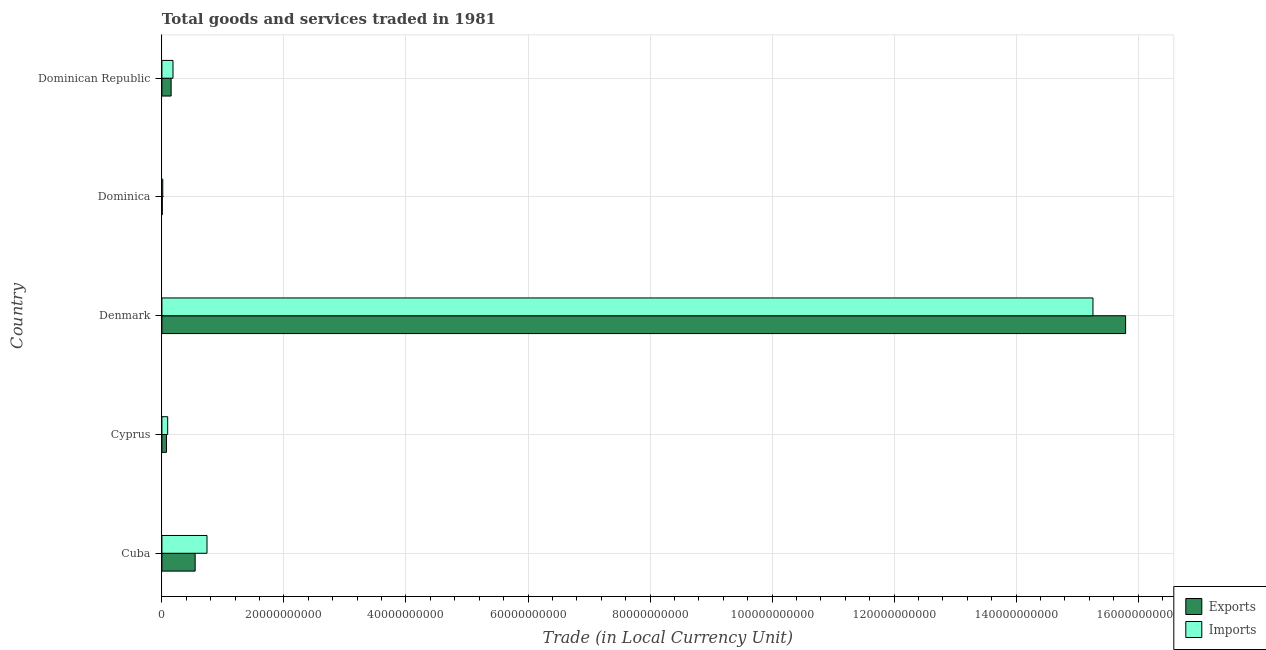Are the number of bars per tick equal to the number of legend labels?
Provide a short and direct response. Yes. What is the label of the 4th group of bars from the top?
Your answer should be very brief. Cyprus. What is the export of goods and services in Denmark?
Provide a short and direct response. 1.58e+11. Across all countries, what is the maximum imports of goods and services?
Make the answer very short. 1.53e+11. Across all countries, what is the minimum export of goods and services?
Offer a very short reply. 6.18e+07. In which country was the export of goods and services maximum?
Your answer should be compact. Denmark. In which country was the imports of goods and services minimum?
Ensure brevity in your answer.  Dominica. What is the total export of goods and services in the graph?
Offer a very short reply. 1.66e+11. What is the difference between the export of goods and services in Cuba and that in Denmark?
Your response must be concise. -1.52e+11. What is the difference between the imports of goods and services in Dominican Republic and the export of goods and services in Cuba?
Your answer should be very brief. -3.63e+09. What is the average imports of goods and services per country?
Your answer should be very brief. 3.26e+1. What is the difference between the export of goods and services and imports of goods and services in Denmark?
Your answer should be compact. 5.35e+09. What is the ratio of the imports of goods and services in Cuba to that in Dominican Republic?
Provide a short and direct response. 4.07. Is the difference between the imports of goods and services in Cuba and Denmark greater than the difference between the export of goods and services in Cuba and Denmark?
Your response must be concise. Yes. What is the difference between the highest and the second highest imports of goods and services?
Make the answer very short. 1.45e+11. What is the difference between the highest and the lowest imports of goods and services?
Your answer should be very brief. 1.52e+11. In how many countries, is the export of goods and services greater than the average export of goods and services taken over all countries?
Offer a terse response. 1. What does the 1st bar from the top in Dominica represents?
Ensure brevity in your answer.  Imports. What does the 2nd bar from the bottom in Dominica represents?
Provide a succinct answer. Imports. How many bars are there?
Keep it short and to the point. 10. Are all the bars in the graph horizontal?
Ensure brevity in your answer.  Yes. How many countries are there in the graph?
Offer a very short reply. 5. What is the difference between two consecutive major ticks on the X-axis?
Offer a very short reply. 2.00e+1. Are the values on the major ticks of X-axis written in scientific E-notation?
Ensure brevity in your answer.  No. Does the graph contain any zero values?
Your response must be concise. No. How many legend labels are there?
Keep it short and to the point. 2. How are the legend labels stacked?
Your answer should be very brief. Vertical. What is the title of the graph?
Provide a short and direct response. Total goods and services traded in 1981. What is the label or title of the X-axis?
Your response must be concise. Trade (in Local Currency Unit). What is the Trade (in Local Currency Unit) of Exports in Cuba?
Keep it short and to the point. 5.45e+09. What is the Trade (in Local Currency Unit) of Imports in Cuba?
Offer a terse response. 7.39e+09. What is the Trade (in Local Currency Unit) of Exports in Cyprus?
Make the answer very short. 7.52e+08. What is the Trade (in Local Currency Unit) of Imports in Cyprus?
Make the answer very short. 9.48e+08. What is the Trade (in Local Currency Unit) of Exports in Denmark?
Your answer should be compact. 1.58e+11. What is the Trade (in Local Currency Unit) of Imports in Denmark?
Your response must be concise. 1.53e+11. What is the Trade (in Local Currency Unit) of Exports in Dominica?
Keep it short and to the point. 6.18e+07. What is the Trade (in Local Currency Unit) in Imports in Dominica?
Your answer should be compact. 1.41e+08. What is the Trade (in Local Currency Unit) in Exports in Dominican Republic?
Keep it short and to the point. 1.51e+09. What is the Trade (in Local Currency Unit) of Imports in Dominican Republic?
Provide a short and direct response. 1.82e+09. Across all countries, what is the maximum Trade (in Local Currency Unit) of Exports?
Make the answer very short. 1.58e+11. Across all countries, what is the maximum Trade (in Local Currency Unit) in Imports?
Offer a terse response. 1.53e+11. Across all countries, what is the minimum Trade (in Local Currency Unit) in Exports?
Offer a very short reply. 6.18e+07. Across all countries, what is the minimum Trade (in Local Currency Unit) in Imports?
Provide a short and direct response. 1.41e+08. What is the total Trade (in Local Currency Unit) of Exports in the graph?
Your answer should be very brief. 1.66e+11. What is the total Trade (in Local Currency Unit) in Imports in the graph?
Provide a short and direct response. 1.63e+11. What is the difference between the Trade (in Local Currency Unit) of Exports in Cuba and that in Cyprus?
Offer a very short reply. 4.70e+09. What is the difference between the Trade (in Local Currency Unit) of Imports in Cuba and that in Cyprus?
Provide a short and direct response. 6.44e+09. What is the difference between the Trade (in Local Currency Unit) of Exports in Cuba and that in Denmark?
Make the answer very short. -1.52e+11. What is the difference between the Trade (in Local Currency Unit) of Imports in Cuba and that in Denmark?
Your answer should be very brief. -1.45e+11. What is the difference between the Trade (in Local Currency Unit) in Exports in Cuba and that in Dominica?
Offer a very short reply. 5.39e+09. What is the difference between the Trade (in Local Currency Unit) in Imports in Cuba and that in Dominica?
Your answer should be compact. 7.25e+09. What is the difference between the Trade (in Local Currency Unit) of Exports in Cuba and that in Dominican Republic?
Your answer should be very brief. 3.94e+09. What is the difference between the Trade (in Local Currency Unit) of Imports in Cuba and that in Dominican Republic?
Your answer should be very brief. 5.57e+09. What is the difference between the Trade (in Local Currency Unit) in Exports in Cyprus and that in Denmark?
Make the answer very short. -1.57e+11. What is the difference between the Trade (in Local Currency Unit) in Imports in Cyprus and that in Denmark?
Your answer should be compact. -1.52e+11. What is the difference between the Trade (in Local Currency Unit) of Exports in Cyprus and that in Dominica?
Your answer should be compact. 6.90e+08. What is the difference between the Trade (in Local Currency Unit) in Imports in Cyprus and that in Dominica?
Keep it short and to the point. 8.07e+08. What is the difference between the Trade (in Local Currency Unit) in Exports in Cyprus and that in Dominican Republic?
Ensure brevity in your answer.  -7.61e+08. What is the difference between the Trade (in Local Currency Unit) of Imports in Cyprus and that in Dominican Republic?
Keep it short and to the point. -8.70e+08. What is the difference between the Trade (in Local Currency Unit) of Exports in Denmark and that in Dominica?
Your response must be concise. 1.58e+11. What is the difference between the Trade (in Local Currency Unit) of Imports in Denmark and that in Dominica?
Provide a short and direct response. 1.52e+11. What is the difference between the Trade (in Local Currency Unit) of Exports in Denmark and that in Dominican Republic?
Offer a very short reply. 1.56e+11. What is the difference between the Trade (in Local Currency Unit) of Imports in Denmark and that in Dominican Republic?
Your answer should be compact. 1.51e+11. What is the difference between the Trade (in Local Currency Unit) of Exports in Dominica and that in Dominican Republic?
Your answer should be very brief. -1.45e+09. What is the difference between the Trade (in Local Currency Unit) in Imports in Dominica and that in Dominican Republic?
Offer a terse response. -1.68e+09. What is the difference between the Trade (in Local Currency Unit) of Exports in Cuba and the Trade (in Local Currency Unit) of Imports in Cyprus?
Your answer should be very brief. 4.50e+09. What is the difference between the Trade (in Local Currency Unit) in Exports in Cuba and the Trade (in Local Currency Unit) in Imports in Denmark?
Your answer should be compact. -1.47e+11. What is the difference between the Trade (in Local Currency Unit) in Exports in Cuba and the Trade (in Local Currency Unit) in Imports in Dominica?
Give a very brief answer. 5.31e+09. What is the difference between the Trade (in Local Currency Unit) in Exports in Cuba and the Trade (in Local Currency Unit) in Imports in Dominican Republic?
Keep it short and to the point. 3.63e+09. What is the difference between the Trade (in Local Currency Unit) in Exports in Cyprus and the Trade (in Local Currency Unit) in Imports in Denmark?
Provide a succinct answer. -1.52e+11. What is the difference between the Trade (in Local Currency Unit) in Exports in Cyprus and the Trade (in Local Currency Unit) in Imports in Dominica?
Offer a terse response. 6.11e+08. What is the difference between the Trade (in Local Currency Unit) in Exports in Cyprus and the Trade (in Local Currency Unit) in Imports in Dominican Republic?
Offer a terse response. -1.07e+09. What is the difference between the Trade (in Local Currency Unit) of Exports in Denmark and the Trade (in Local Currency Unit) of Imports in Dominica?
Make the answer very short. 1.58e+11. What is the difference between the Trade (in Local Currency Unit) in Exports in Denmark and the Trade (in Local Currency Unit) in Imports in Dominican Republic?
Your answer should be compact. 1.56e+11. What is the difference between the Trade (in Local Currency Unit) in Exports in Dominica and the Trade (in Local Currency Unit) in Imports in Dominican Republic?
Keep it short and to the point. -1.76e+09. What is the average Trade (in Local Currency Unit) of Exports per country?
Give a very brief answer. 3.31e+1. What is the average Trade (in Local Currency Unit) of Imports per country?
Offer a terse response. 3.26e+1. What is the difference between the Trade (in Local Currency Unit) in Exports and Trade (in Local Currency Unit) in Imports in Cuba?
Provide a short and direct response. -1.94e+09. What is the difference between the Trade (in Local Currency Unit) in Exports and Trade (in Local Currency Unit) in Imports in Cyprus?
Offer a very short reply. -1.96e+08. What is the difference between the Trade (in Local Currency Unit) of Exports and Trade (in Local Currency Unit) of Imports in Denmark?
Your answer should be compact. 5.35e+09. What is the difference between the Trade (in Local Currency Unit) of Exports and Trade (in Local Currency Unit) of Imports in Dominica?
Offer a terse response. -7.89e+07. What is the difference between the Trade (in Local Currency Unit) of Exports and Trade (in Local Currency Unit) of Imports in Dominican Republic?
Make the answer very short. -3.05e+08. What is the ratio of the Trade (in Local Currency Unit) of Exports in Cuba to that in Cyprus?
Keep it short and to the point. 7.25. What is the ratio of the Trade (in Local Currency Unit) of Imports in Cuba to that in Cyprus?
Offer a terse response. 7.8. What is the ratio of the Trade (in Local Currency Unit) of Exports in Cuba to that in Denmark?
Ensure brevity in your answer.  0.03. What is the ratio of the Trade (in Local Currency Unit) of Imports in Cuba to that in Denmark?
Offer a very short reply. 0.05. What is the ratio of the Trade (in Local Currency Unit) in Exports in Cuba to that in Dominica?
Provide a short and direct response. 88.18. What is the ratio of the Trade (in Local Currency Unit) of Imports in Cuba to that in Dominica?
Provide a short and direct response. 52.54. What is the ratio of the Trade (in Local Currency Unit) of Exports in Cuba to that in Dominican Republic?
Give a very brief answer. 3.6. What is the ratio of the Trade (in Local Currency Unit) of Imports in Cuba to that in Dominican Republic?
Keep it short and to the point. 4.07. What is the ratio of the Trade (in Local Currency Unit) in Exports in Cyprus to that in Denmark?
Offer a terse response. 0. What is the ratio of the Trade (in Local Currency Unit) in Imports in Cyprus to that in Denmark?
Keep it short and to the point. 0.01. What is the ratio of the Trade (in Local Currency Unit) of Exports in Cyprus to that in Dominica?
Your response must be concise. 12.17. What is the ratio of the Trade (in Local Currency Unit) of Imports in Cyprus to that in Dominica?
Your response must be concise. 6.74. What is the ratio of the Trade (in Local Currency Unit) in Exports in Cyprus to that in Dominican Republic?
Your answer should be compact. 0.5. What is the ratio of the Trade (in Local Currency Unit) of Imports in Cyprus to that in Dominican Republic?
Your answer should be compact. 0.52. What is the ratio of the Trade (in Local Currency Unit) of Exports in Denmark to that in Dominica?
Provide a succinct answer. 2555.58. What is the ratio of the Trade (in Local Currency Unit) in Imports in Denmark to that in Dominica?
Offer a very short reply. 1084.47. What is the ratio of the Trade (in Local Currency Unit) in Exports in Denmark to that in Dominican Republic?
Provide a succinct answer. 104.39. What is the ratio of the Trade (in Local Currency Unit) in Imports in Denmark to that in Dominican Republic?
Make the answer very short. 83.93. What is the ratio of the Trade (in Local Currency Unit) in Exports in Dominica to that in Dominican Republic?
Your response must be concise. 0.04. What is the ratio of the Trade (in Local Currency Unit) in Imports in Dominica to that in Dominican Republic?
Your response must be concise. 0.08. What is the difference between the highest and the second highest Trade (in Local Currency Unit) of Exports?
Provide a short and direct response. 1.52e+11. What is the difference between the highest and the second highest Trade (in Local Currency Unit) in Imports?
Offer a terse response. 1.45e+11. What is the difference between the highest and the lowest Trade (in Local Currency Unit) of Exports?
Provide a short and direct response. 1.58e+11. What is the difference between the highest and the lowest Trade (in Local Currency Unit) in Imports?
Provide a short and direct response. 1.52e+11. 